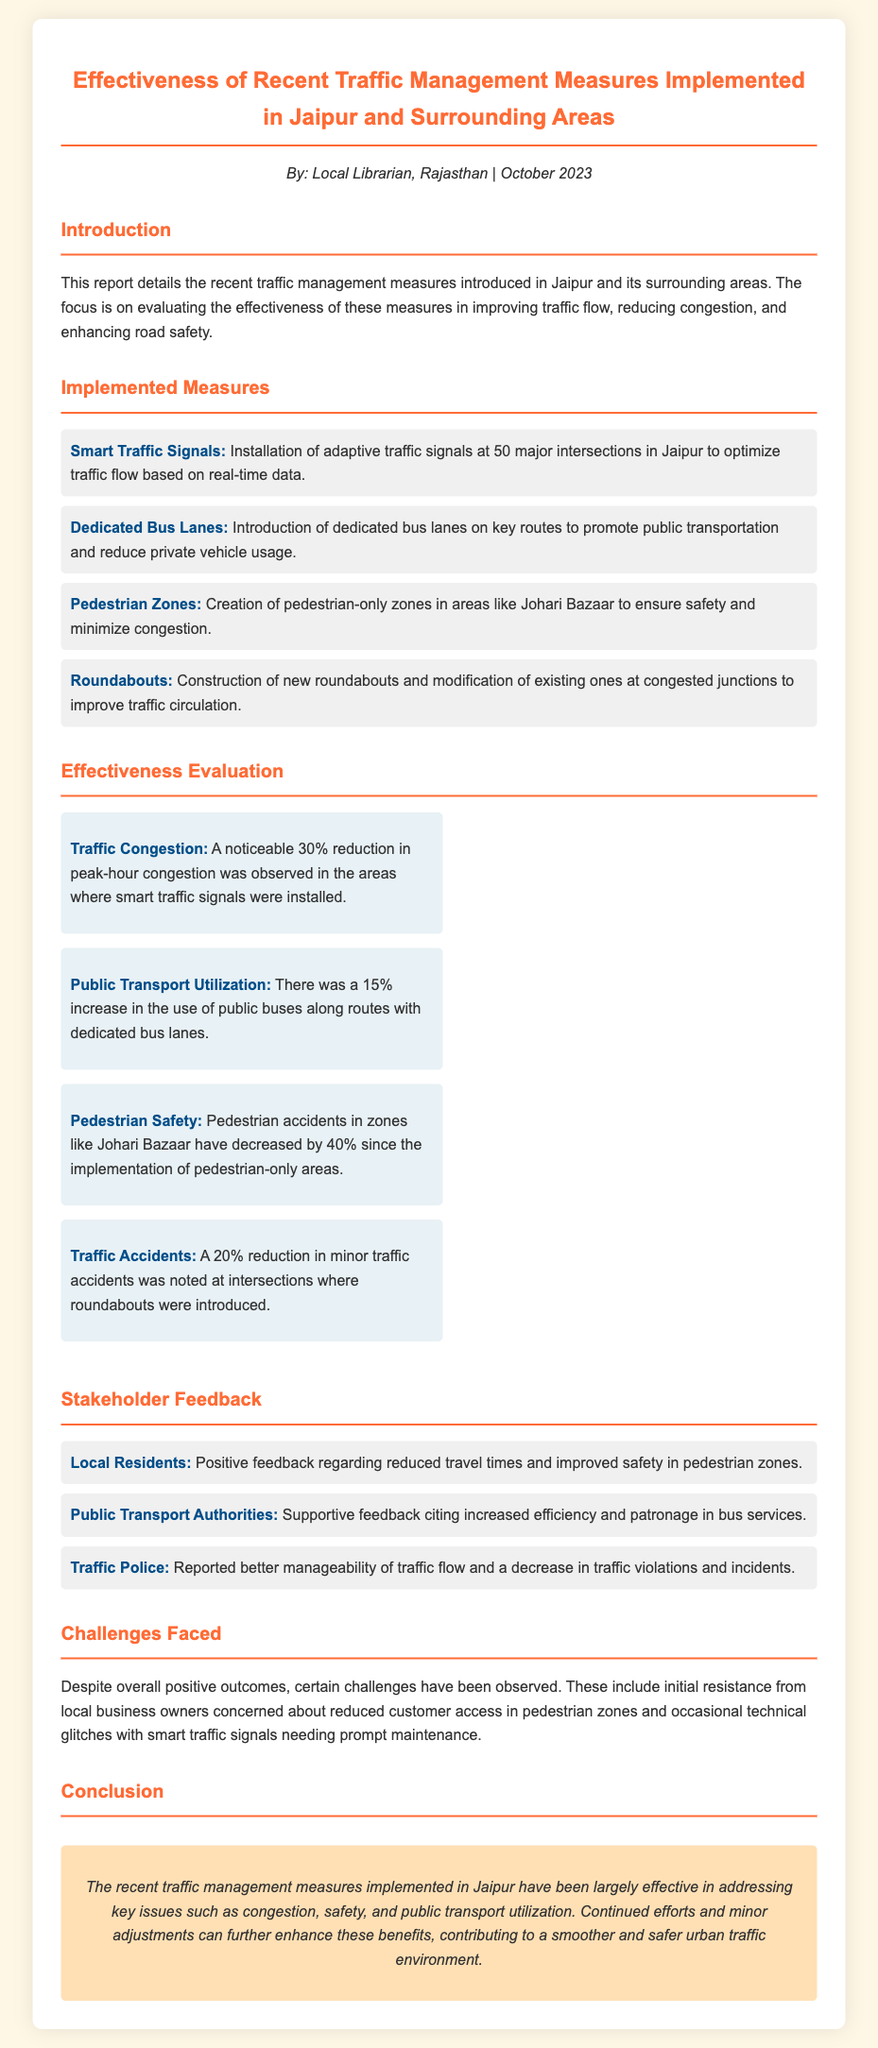What measures were implemented to improve traffic management? The section titled "Implemented Measures" lists four measures including Smart Traffic Signals, Dedicated Bus Lanes, Pedestrian Zones, and Roundabouts.
Answer: Smart Traffic Signals, Dedicated Bus Lanes, Pedestrian Zones, Roundabouts What percentage reduction in peak-hour congestion was observed? The report states that there was a noticeable 30% reduction in peak-hour congestion at intersections with smart traffic signals.
Answer: 30% Which area experienced a 40% decrease in pedestrian accidents? The effectiveness criteria highlighted a 40% decrease in pedestrian accidents in zones like Johari Bazaar after implementing pedestrian-only areas.
Answer: Johari Bazaar What was the increase in public transport utilization following the new bus lanes? The report mentions a 15% increase in public buses' use along routes with dedicated bus lanes.
Answer: 15% What feedback did local residents provide regarding the traffic measures? The document indicates that local residents gave positive feedback about reduced travel times and improved safety in pedestrian zones.
Answer: Positive feedback Which stakeholder reported a decrease in traffic violations? The Traffic Police reported better manageability of traffic flow and a decrease in traffic violations.
Answer: Traffic Police What challenge was faced regarding pedestrian zones? The report notes initial resistance from local business owners concerned about reduced customer access in pedestrian zones.
Answer: Reduced customer access What overall conclusion is drawn about the traffic measures' effectiveness? The conclusion emphasizes that the traffic management measures have been largely effective in addressing congestion, safety, and public transport utilization.
Answer: Largely effective 